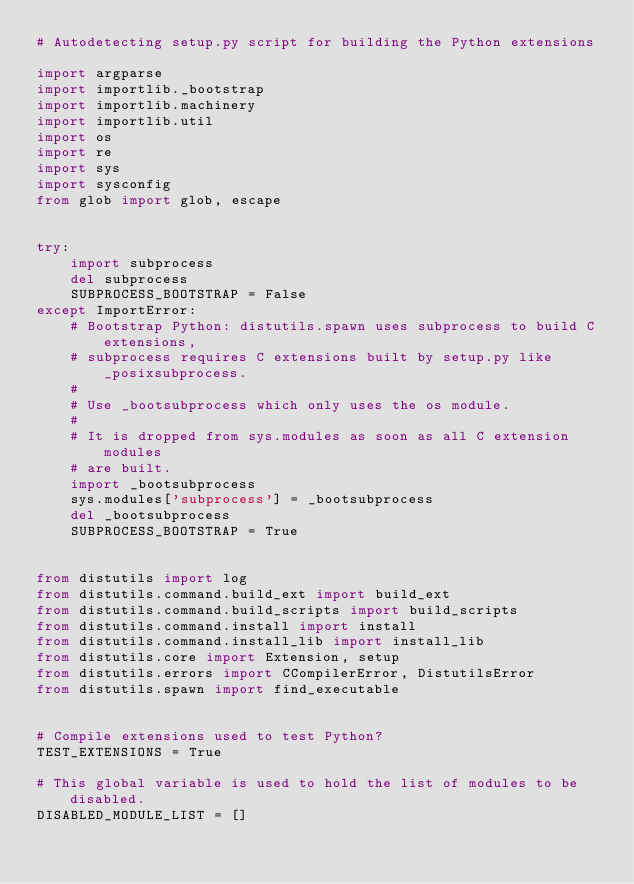<code> <loc_0><loc_0><loc_500><loc_500><_Python_># Autodetecting setup.py script for building the Python extensions

import argparse
import importlib._bootstrap
import importlib.machinery
import importlib.util
import os
import re
import sys
import sysconfig
from glob import glob, escape


try:
    import subprocess
    del subprocess
    SUBPROCESS_BOOTSTRAP = False
except ImportError:
    # Bootstrap Python: distutils.spawn uses subprocess to build C extensions,
    # subprocess requires C extensions built by setup.py like _posixsubprocess.
    #
    # Use _bootsubprocess which only uses the os module.
    #
    # It is dropped from sys.modules as soon as all C extension modules
    # are built.
    import _bootsubprocess
    sys.modules['subprocess'] = _bootsubprocess
    del _bootsubprocess
    SUBPROCESS_BOOTSTRAP = True


from distutils import log
from distutils.command.build_ext import build_ext
from distutils.command.build_scripts import build_scripts
from distutils.command.install import install
from distutils.command.install_lib import install_lib
from distutils.core import Extension, setup
from distutils.errors import CCompilerError, DistutilsError
from distutils.spawn import find_executable


# Compile extensions used to test Python?
TEST_EXTENSIONS = True

# This global variable is used to hold the list of modules to be disabled.
DISABLED_MODULE_LIST = []

</code> 